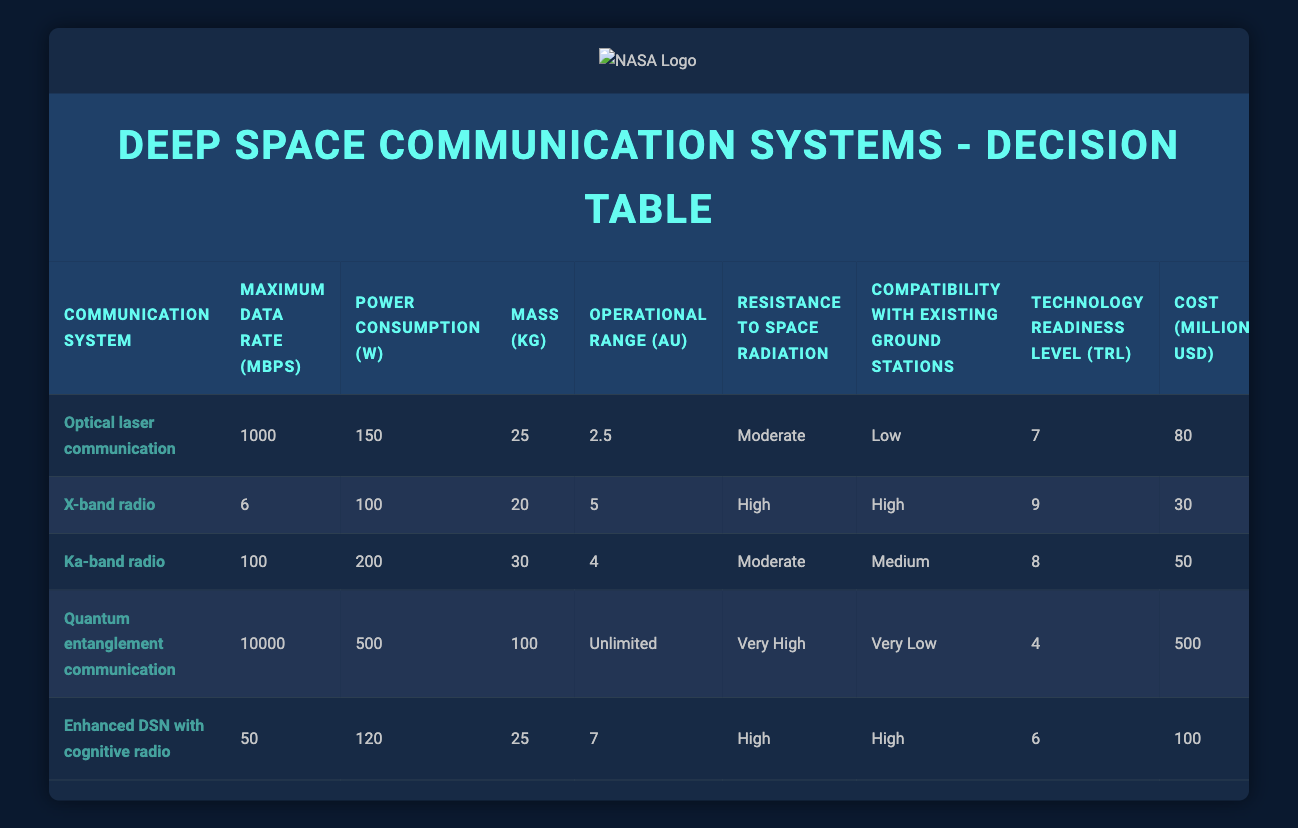What is the maximum data rate for Quantum entanglement communication? According to the table, the maximum data rate for Quantum entanglement communication is 10000 Mbps.
Answer: 10000 Mbps Which communication system has the lowest power consumption? By examining the table, the system with the lowest power consumption is X-band radio, which consumes 100 W.
Answer: X-band radio What is the average mass of the communication systems listed? The masses of the systems are 25, 20, 30, 100, and 25 kg. Summing these values gives 300 kg. To find the average, divide by the number of systems (5): 300/5 = 60 kg.
Answer: 60 kg Is the Optical laser communication compatible with existing ground stations? According to the table, the compatibility of Optical laser communication with existing ground stations is marked as Low. Therefore, it is not compatible.
Answer: No Which system has the highest Technology readiness level (TRL)? From the table, X-band radio has the highest TRL at 9, when compared to the other systems.
Answer: 9 How much cost would it take to implement the Ka-band radio system compared to the Enhanced DSN with cognitive radio? The cost for Ka-band radio is 50 million USD and for Enhanced DSN with cognitive radio, it is 100 million USD. The difference is 100 - 50 = 50 million USD, indicating that Enhanced DSN with cognitive radio costs an additional 50 million USD.
Answer: 50 million USD Does the Enhanced DSN with cognitive radio offer higher resistance to space radiation than Ka-band radio? The resistance to space radiation for Enhanced DSN with cognitive radio is High, while for Ka-band radio, it is Moderate. Hence, Enhanced DSN does offer higher resistance.
Answer: Yes What is the operational range of the system with the highest maximum data rate? The system with the highest maximum data rate is Quantum entanglement communication at 10000 Mbps, and its operational range is Unlimited according to the table.
Answer: Unlimited 